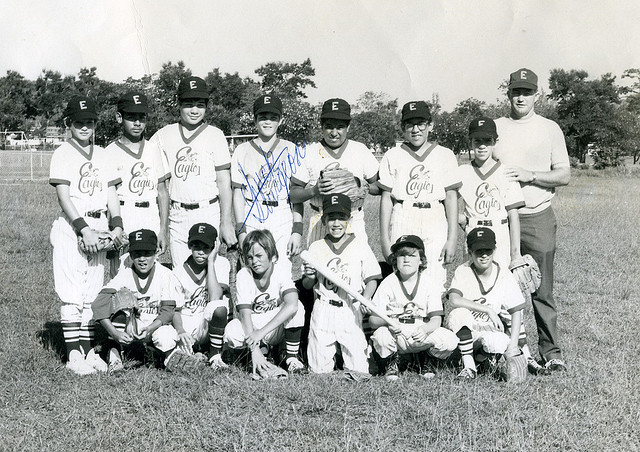Please transcribe the text in this image. Eagles E E E E E E E F E E So 